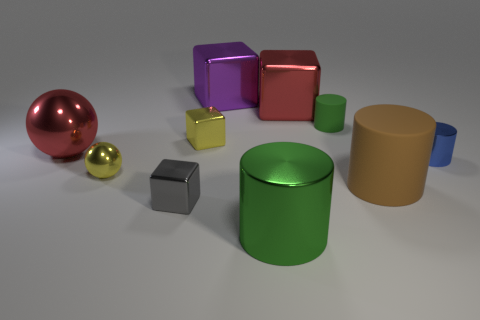Subtract all yellow blocks. How many blocks are left? 3 Subtract all balls. How many objects are left? 8 Subtract all purple balls. How many green cylinders are left? 2 Add 2 gray metal things. How many gray metal things are left? 3 Add 7 tiny cyan cylinders. How many tiny cyan cylinders exist? 7 Subtract 1 brown cylinders. How many objects are left? 9 Subtract 1 spheres. How many spheres are left? 1 Subtract all brown balls. Subtract all cyan cylinders. How many balls are left? 2 Subtract all shiny objects. Subtract all big green metallic balls. How many objects are left? 2 